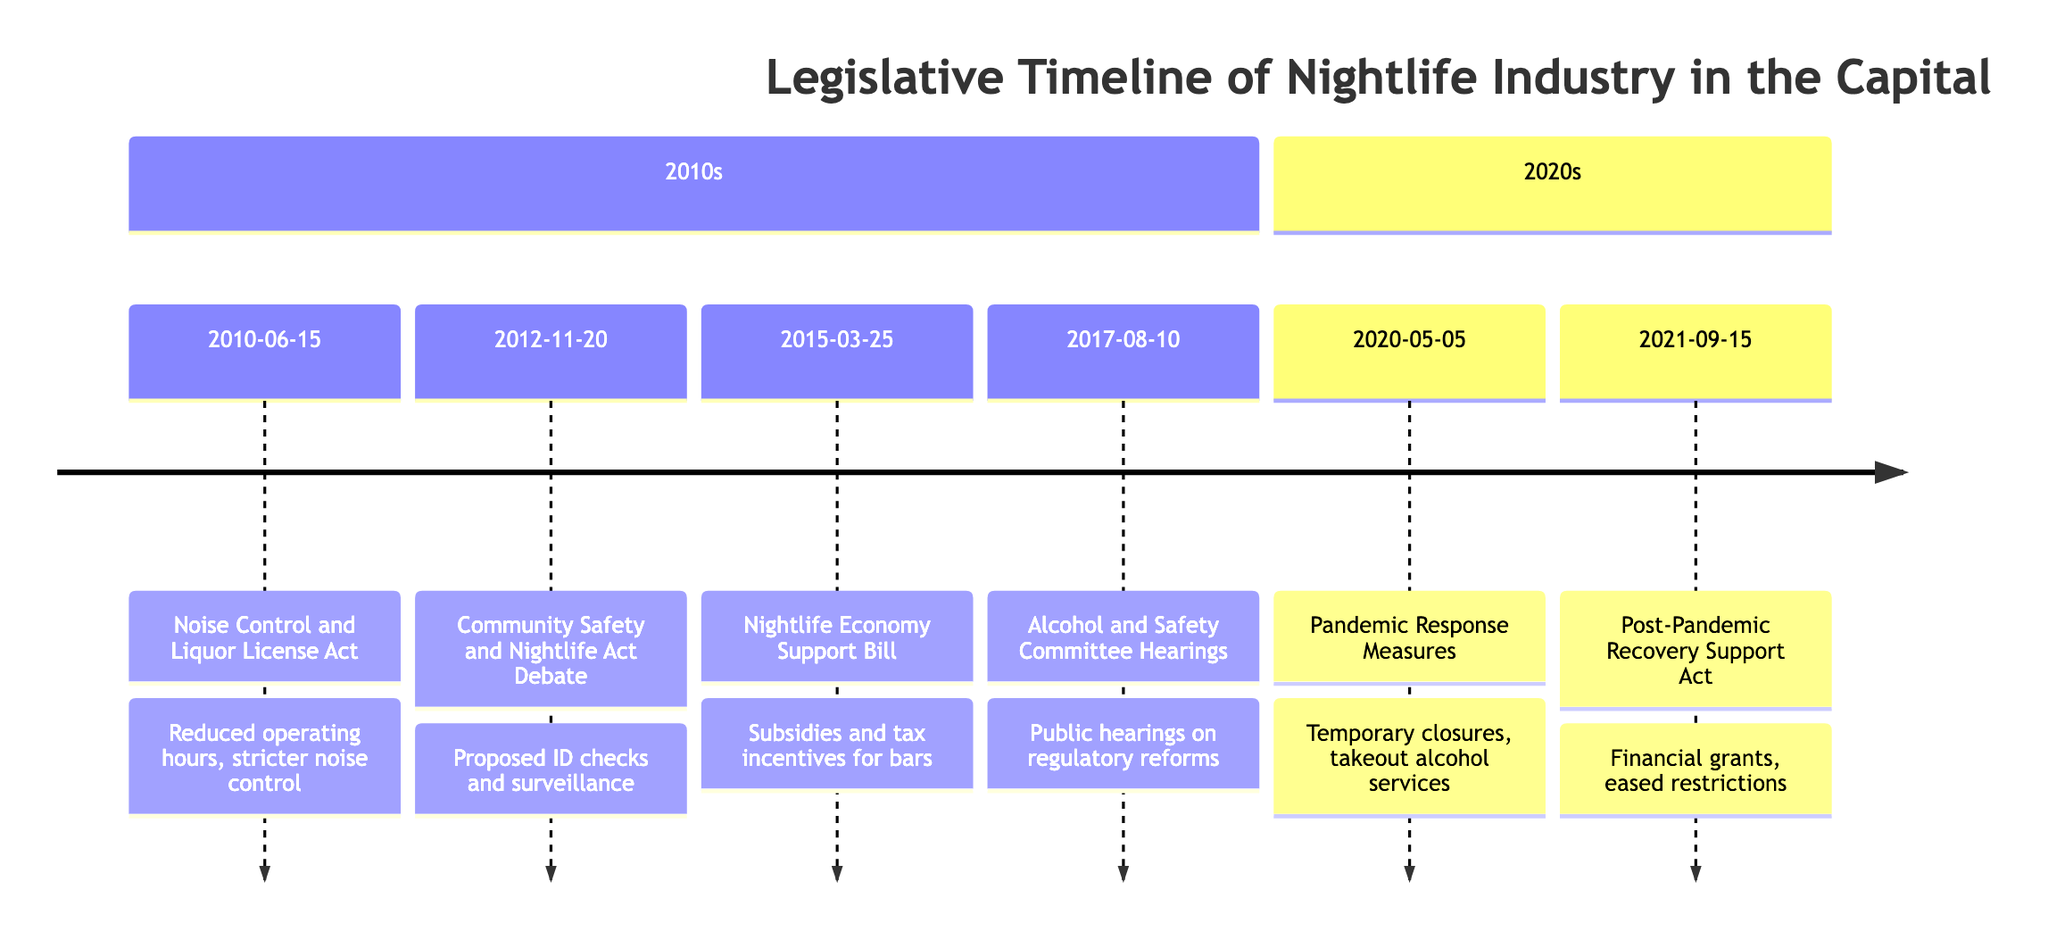what is the first event in the timeline? The timeline starts with the event "Noise Control and Liquor License Act," which is listed on the date 2010-06-15.
Answer: Noise Control and Liquor License Act how many events are listed in the timeline? There are a total of six events documented in the timeline, ranging from 2010 to 2021.
Answer: 6 what was the public reaction to the Nightlife Economy Support Bill? The public reaction to the Nightlife Economy Support Bill was widely supportive, particularly from bar owners and industry stakeholders.
Answer: Widely supported what is the date for the Pandemic Response Measures for Nightlife? The date for the Pandemic Response Measures for Nightlife is 2020-05-05, as indicated on the timeline.
Answer: 2020-05-05 which event involved public hearings on regulatory reforms? The event involving public hearings on regulatory reforms is titled "Alcohol and Safety Committee Hearings," occurring on 2017-08-10.
Answer: Alcohol and Safety Committee Hearings what was a significant impact of the Community Safety and Nightlife Act debate? A significant impact of the Community Safety and Nightlife Act debate included the proposal for mandatory ID checks and surveillance cameras in nightlife areas.
Answer: Mandatory ID checks and surveillance cameras what is the chronological order of events from 2015 to 2021? The chronological order of events from 2015 to 2021 is: Nightlife Economy Support Bill on 2015-03-25, Alcohol and Safety Committee Hearings on 2017-08-10, Pandemic Response Measures on 2020-05-05, and Post-Pandemic Recovery Support Act on 2021-09-15.
Answer: Nightlife Economy Support Bill, Alcohol and Safety Committee Hearings, Pandemic Response Measures, Post-Pandemic Recovery Support Act what impact did the Post-Pandemic Recovery Support Act have on nightlife businesses? The impact of the Post-Pandemic Recovery Support Act included financial grants, eased restrictions, and promotional campaigns to support the recovery of nightlife businesses after the pandemic.
Answer: Financial grants, eased restrictions, promotional campaigns which event was controversial due to privacy concerns? The event that was controversial due to privacy concerns was the "Community Safety and Nightlife Act" debate held on 2012-11-20.
Answer: Community Safety and Nightlife Act debate 